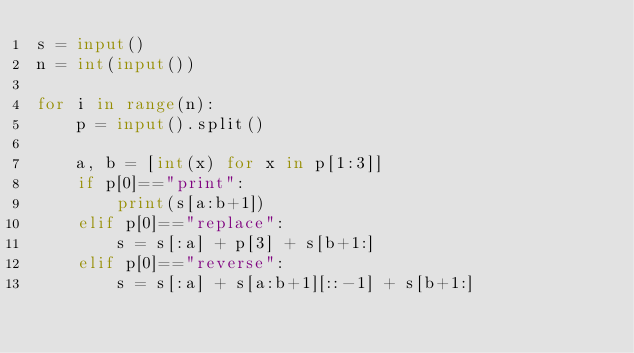<code> <loc_0><loc_0><loc_500><loc_500><_Python_>s = input()
n = int(input())

for i in range(n):
    p = input().split()

    a, b = [int(x) for x in p[1:3]]
    if p[0]=="print":
        print(s[a:b+1])
    elif p[0]=="replace":
        s = s[:a] + p[3] + s[b+1:]
    elif p[0]=="reverse":
        s = s[:a] + s[a:b+1][::-1] + s[b+1:]</code> 